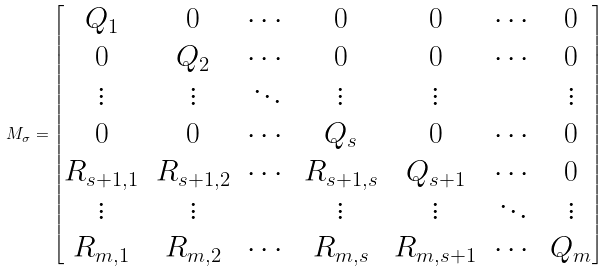Convert formula to latex. <formula><loc_0><loc_0><loc_500><loc_500>M _ { \sigma } = \begin{bmatrix} Q _ { 1 } & 0 & \cdots & 0 & 0 & \cdots & 0 \\ 0 & Q _ { 2 } & \cdots & 0 & 0 & \cdots & 0 \\ \vdots & \vdots & \ddots & \vdots & \vdots & & \vdots \\ 0 & 0 & \cdots & Q _ { s } & 0 & \cdots & 0 \\ R _ { s + 1 , 1 } & R _ { s + 1 , 2 } & \cdots & R _ { s + 1 , s } & Q _ { s + 1 } & \cdots & 0 \\ \vdots & \vdots & & \vdots & \vdots & \ddots & \vdots \\ R _ { m , 1 } & R _ { m , 2 } & \cdots & R _ { m , s } & R _ { m , s + 1 } & \cdots & Q _ { m } \end{bmatrix}</formula> 